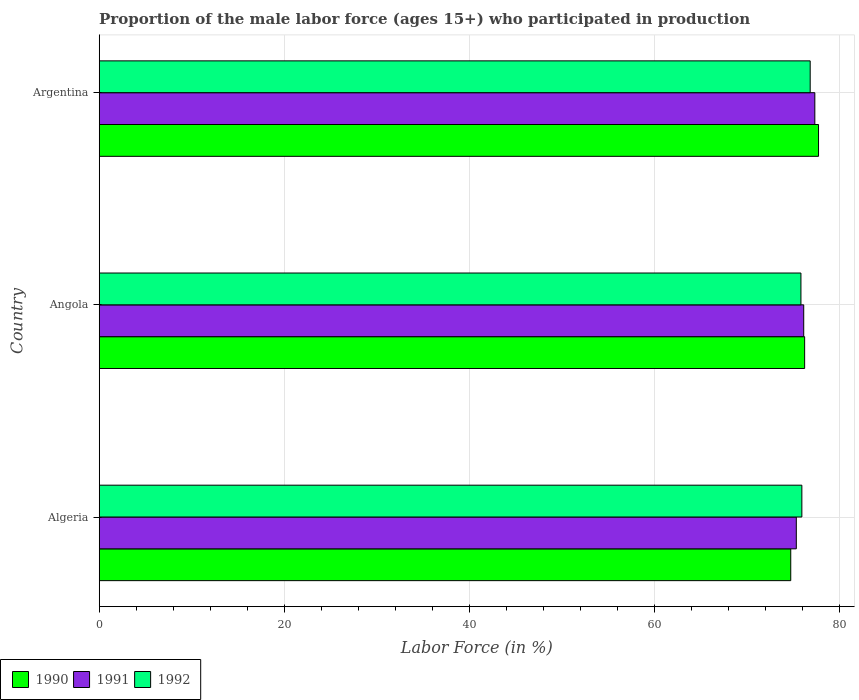How many different coloured bars are there?
Provide a short and direct response. 3. How many groups of bars are there?
Give a very brief answer. 3. Are the number of bars per tick equal to the number of legend labels?
Make the answer very short. Yes. Are the number of bars on each tick of the Y-axis equal?
Offer a terse response. Yes. How many bars are there on the 1st tick from the bottom?
Offer a terse response. 3. What is the label of the 1st group of bars from the top?
Offer a terse response. Argentina. What is the proportion of the male labor force who participated in production in 1990 in Angola?
Your answer should be very brief. 76.2. Across all countries, what is the maximum proportion of the male labor force who participated in production in 1992?
Provide a short and direct response. 76.8. Across all countries, what is the minimum proportion of the male labor force who participated in production in 1992?
Offer a terse response. 75.8. In which country was the proportion of the male labor force who participated in production in 1990 maximum?
Keep it short and to the point. Argentina. In which country was the proportion of the male labor force who participated in production in 1990 minimum?
Give a very brief answer. Algeria. What is the total proportion of the male labor force who participated in production in 1992 in the graph?
Provide a short and direct response. 228.5. What is the difference between the proportion of the male labor force who participated in production in 1990 in Angola and that in Argentina?
Keep it short and to the point. -1.5. What is the difference between the proportion of the male labor force who participated in production in 1992 in Argentina and the proportion of the male labor force who participated in production in 1990 in Algeria?
Your response must be concise. 2.1. What is the average proportion of the male labor force who participated in production in 1992 per country?
Offer a terse response. 76.17. What is the difference between the proportion of the male labor force who participated in production in 1991 and proportion of the male labor force who participated in production in 1990 in Angola?
Give a very brief answer. -0.1. What is the ratio of the proportion of the male labor force who participated in production in 1992 in Angola to that in Argentina?
Your answer should be compact. 0.99. Is the proportion of the male labor force who participated in production in 1992 in Algeria less than that in Angola?
Your answer should be very brief. No. Is the difference between the proportion of the male labor force who participated in production in 1991 in Algeria and Argentina greater than the difference between the proportion of the male labor force who participated in production in 1990 in Algeria and Argentina?
Give a very brief answer. Yes. What is the difference between the highest and the second highest proportion of the male labor force who participated in production in 1992?
Your answer should be very brief. 0.9. In how many countries, is the proportion of the male labor force who participated in production in 1992 greater than the average proportion of the male labor force who participated in production in 1992 taken over all countries?
Your response must be concise. 1. Is it the case that in every country, the sum of the proportion of the male labor force who participated in production in 1991 and proportion of the male labor force who participated in production in 1992 is greater than the proportion of the male labor force who participated in production in 1990?
Offer a very short reply. Yes. Are all the bars in the graph horizontal?
Keep it short and to the point. Yes. Are the values on the major ticks of X-axis written in scientific E-notation?
Give a very brief answer. No. Does the graph contain any zero values?
Keep it short and to the point. No. Does the graph contain grids?
Offer a very short reply. Yes. Where does the legend appear in the graph?
Make the answer very short. Bottom left. What is the title of the graph?
Your answer should be compact. Proportion of the male labor force (ages 15+) who participated in production. Does "1980" appear as one of the legend labels in the graph?
Ensure brevity in your answer.  No. What is the label or title of the Y-axis?
Your response must be concise. Country. What is the Labor Force (in %) of 1990 in Algeria?
Your response must be concise. 74.7. What is the Labor Force (in %) in 1991 in Algeria?
Your answer should be very brief. 75.3. What is the Labor Force (in %) in 1992 in Algeria?
Provide a succinct answer. 75.9. What is the Labor Force (in %) of 1990 in Angola?
Offer a very short reply. 76.2. What is the Labor Force (in %) of 1991 in Angola?
Provide a short and direct response. 76.1. What is the Labor Force (in %) in 1992 in Angola?
Provide a short and direct response. 75.8. What is the Labor Force (in %) of 1990 in Argentina?
Ensure brevity in your answer.  77.7. What is the Labor Force (in %) of 1991 in Argentina?
Offer a terse response. 77.3. What is the Labor Force (in %) of 1992 in Argentina?
Offer a terse response. 76.8. Across all countries, what is the maximum Labor Force (in %) of 1990?
Provide a succinct answer. 77.7. Across all countries, what is the maximum Labor Force (in %) of 1991?
Provide a succinct answer. 77.3. Across all countries, what is the maximum Labor Force (in %) of 1992?
Ensure brevity in your answer.  76.8. Across all countries, what is the minimum Labor Force (in %) in 1990?
Make the answer very short. 74.7. Across all countries, what is the minimum Labor Force (in %) of 1991?
Give a very brief answer. 75.3. Across all countries, what is the minimum Labor Force (in %) in 1992?
Ensure brevity in your answer.  75.8. What is the total Labor Force (in %) in 1990 in the graph?
Offer a terse response. 228.6. What is the total Labor Force (in %) of 1991 in the graph?
Ensure brevity in your answer.  228.7. What is the total Labor Force (in %) in 1992 in the graph?
Provide a succinct answer. 228.5. What is the difference between the Labor Force (in %) in 1991 in Algeria and that in Angola?
Provide a short and direct response. -0.8. What is the difference between the Labor Force (in %) in 1992 in Algeria and that in Angola?
Your answer should be very brief. 0.1. What is the difference between the Labor Force (in %) in 1990 in Algeria and that in Argentina?
Keep it short and to the point. -3. What is the difference between the Labor Force (in %) in 1992 in Algeria and that in Argentina?
Your answer should be compact. -0.9. What is the difference between the Labor Force (in %) of 1990 in Angola and that in Argentina?
Your answer should be compact. -1.5. What is the difference between the Labor Force (in %) of 1992 in Angola and that in Argentina?
Provide a short and direct response. -1. What is the difference between the Labor Force (in %) in 1991 in Algeria and the Labor Force (in %) in 1992 in Angola?
Offer a terse response. -0.5. What is the difference between the Labor Force (in %) of 1990 in Algeria and the Labor Force (in %) of 1991 in Argentina?
Ensure brevity in your answer.  -2.6. What is the difference between the Labor Force (in %) in 1991 in Algeria and the Labor Force (in %) in 1992 in Argentina?
Offer a terse response. -1.5. What is the difference between the Labor Force (in %) of 1990 in Angola and the Labor Force (in %) of 1991 in Argentina?
Offer a very short reply. -1.1. What is the difference between the Labor Force (in %) of 1990 in Angola and the Labor Force (in %) of 1992 in Argentina?
Provide a short and direct response. -0.6. What is the average Labor Force (in %) of 1990 per country?
Offer a very short reply. 76.2. What is the average Labor Force (in %) of 1991 per country?
Offer a terse response. 76.23. What is the average Labor Force (in %) in 1992 per country?
Keep it short and to the point. 76.17. What is the difference between the Labor Force (in %) of 1990 and Labor Force (in %) of 1991 in Algeria?
Keep it short and to the point. -0.6. What is the difference between the Labor Force (in %) in 1990 and Labor Force (in %) in 1992 in Angola?
Ensure brevity in your answer.  0.4. What is the difference between the Labor Force (in %) in 1990 and Labor Force (in %) in 1992 in Argentina?
Offer a very short reply. 0.9. What is the ratio of the Labor Force (in %) of 1990 in Algeria to that in Angola?
Offer a terse response. 0.98. What is the ratio of the Labor Force (in %) of 1992 in Algeria to that in Angola?
Provide a short and direct response. 1. What is the ratio of the Labor Force (in %) of 1990 in Algeria to that in Argentina?
Offer a very short reply. 0.96. What is the ratio of the Labor Force (in %) in 1991 in Algeria to that in Argentina?
Provide a short and direct response. 0.97. What is the ratio of the Labor Force (in %) in 1992 in Algeria to that in Argentina?
Make the answer very short. 0.99. What is the ratio of the Labor Force (in %) in 1990 in Angola to that in Argentina?
Provide a short and direct response. 0.98. What is the ratio of the Labor Force (in %) in 1991 in Angola to that in Argentina?
Keep it short and to the point. 0.98. What is the ratio of the Labor Force (in %) in 1992 in Angola to that in Argentina?
Provide a succinct answer. 0.99. What is the difference between the highest and the second highest Labor Force (in %) in 1991?
Make the answer very short. 1.2. What is the difference between the highest and the second highest Labor Force (in %) of 1992?
Your answer should be very brief. 0.9. What is the difference between the highest and the lowest Labor Force (in %) of 1990?
Offer a very short reply. 3. 